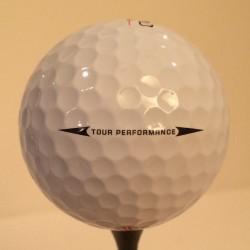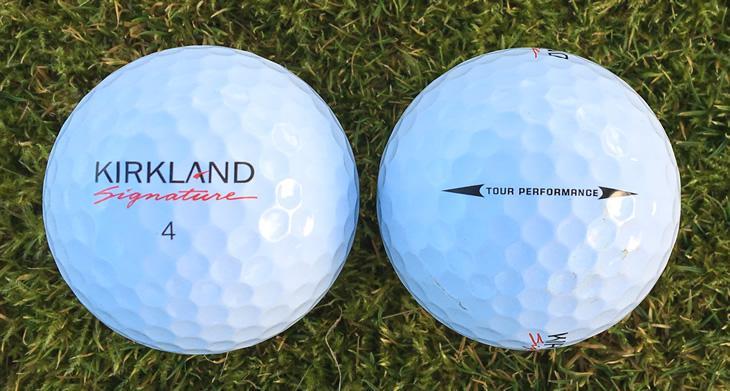The first image is the image on the left, the second image is the image on the right. Given the left and right images, does the statement "There are three golf balls" hold true? Answer yes or no. Yes. 